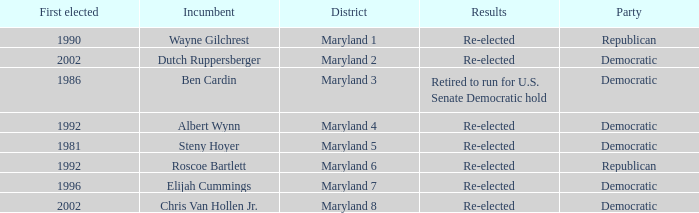What are the results of the incumbent who was first elected in 1996? Re-elected. 